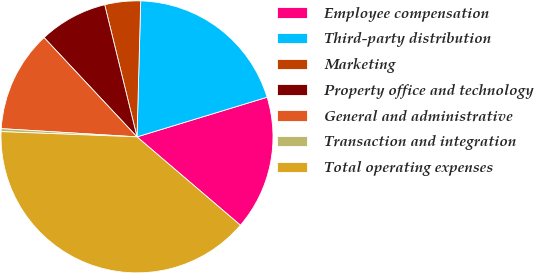Convert chart. <chart><loc_0><loc_0><loc_500><loc_500><pie_chart><fcel>Employee compensation<fcel>Third-party distribution<fcel>Marketing<fcel>Property office and technology<fcel>General and administrative<fcel>Transaction and integration<fcel>Total operating expenses<nl><fcel>15.96%<fcel>19.86%<fcel>4.25%<fcel>8.16%<fcel>12.06%<fcel>0.35%<fcel>39.36%<nl></chart> 